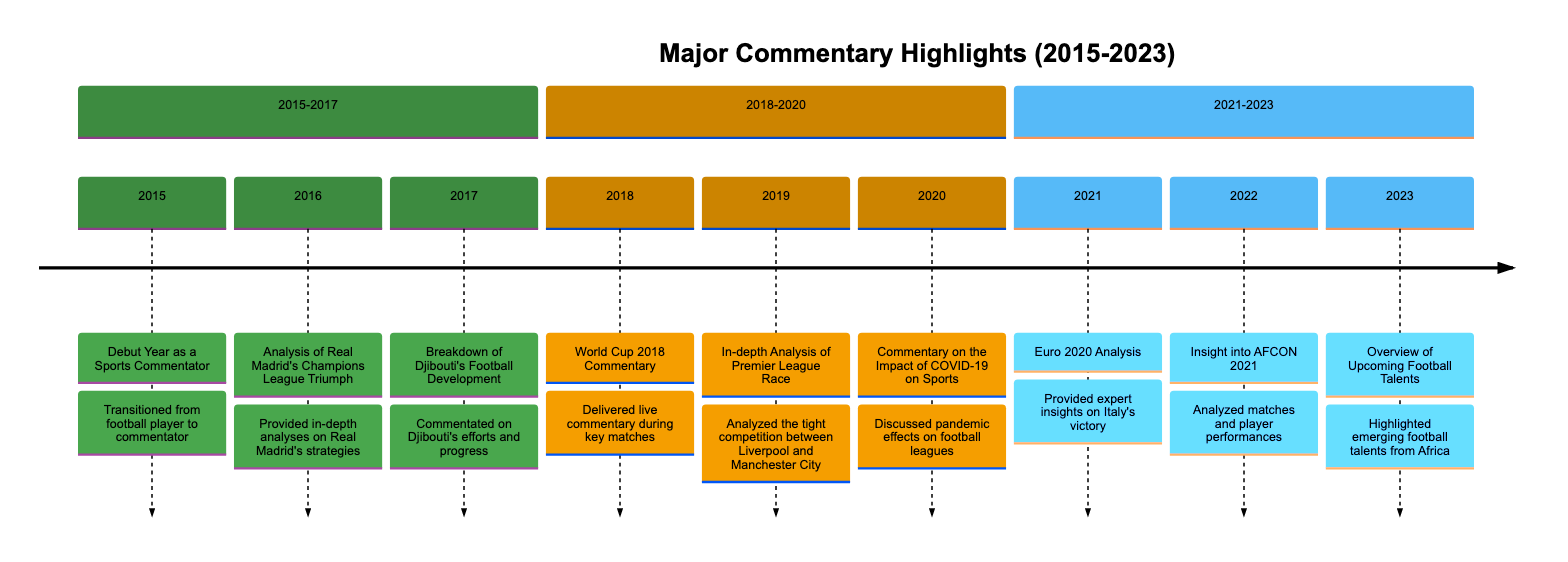What was the debut year as a sports commentator? The timeline indicates that 2015 is marked as the "Debut Year as a Sports Commentator."
Answer: 2015 Which team did Real Madrid defeat in the 2016 Champions League final? The highlight for 2016 notes that Real Madrid won against Atlético Madrid in the final.
Answer: Atlético Madrid What year did you provide insights on Italy's victory in Euro 2020? According to the timeline, the analysis of Italy's victory took place in 2021, which is noted as "Euro 2020 Analysis."
Answer: 2021 How many key commentary events are noted for the year 2018? The timeline lists one major commentary event for 2018, which is "World Cup 2018 Commentary."
Answer: 1 What major global event affected sports commentary in 2020? The highlight for 2020 discusses how COVID-19 impacted sports, indicating it was the major global event.
Answer: COVID-19 In which year did you analyze Premier League competition? The timeline details that the in-depth analysis of the Premier League race occurred in 2019.
Answer: 2019 What aspect was focused on in the 2022 analysis of AFCON? The highlight for 2022 states that matches and player performances were analyzed during AFCON 2021.
Answer: Matches and player performances Which year showcases an overview of upcoming football talents from Africa? The timeline indicates that such an overview is presented in 2023, concluding the major highlights.
Answer: 2023 Which section covers commentary highlights from 2015 to 2017? The timeline explicitly labels the section containing the years 2015, 2016, and 2017.
Answer: 2015-2017 